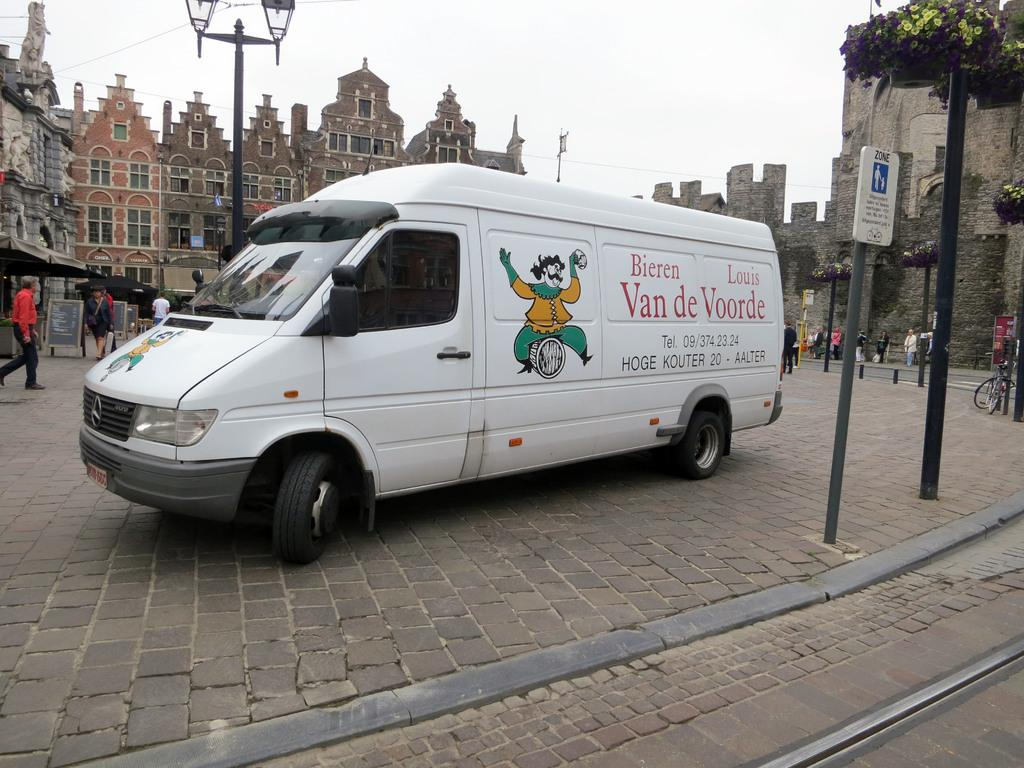<image>
Share a concise interpretation of the image provided. A van for Bieren Van de Voorde drives through a street. 